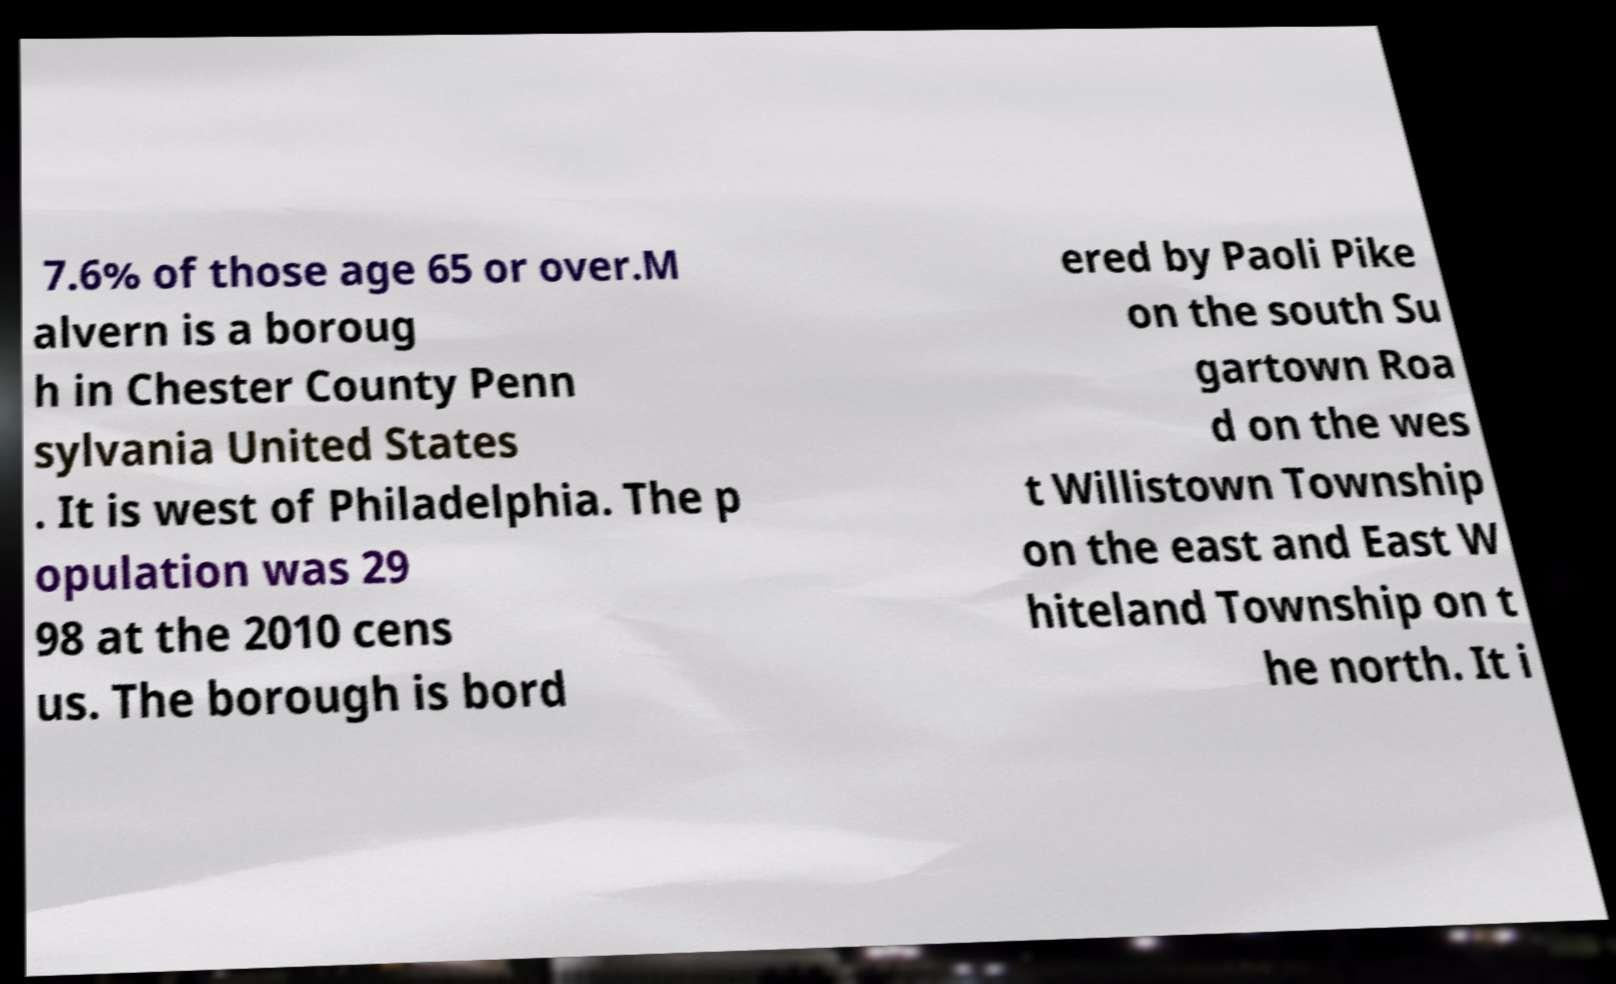Can you read and provide the text displayed in the image?This photo seems to have some interesting text. Can you extract and type it out for me? 7.6% of those age 65 or over.M alvern is a boroug h in Chester County Penn sylvania United States . It is west of Philadelphia. The p opulation was 29 98 at the 2010 cens us. The borough is bord ered by Paoli Pike on the south Su gartown Roa d on the wes t Willistown Township on the east and East W hiteland Township on t he north. It i 